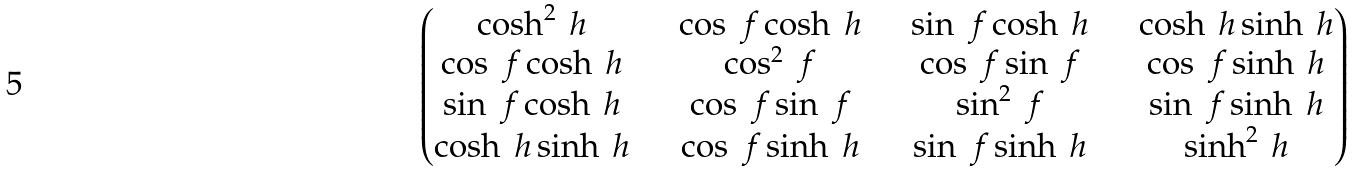Convert formula to latex. <formula><loc_0><loc_0><loc_500><loc_500>\begin{pmatrix} \cosh ^ { 2 } \ h & \quad \cos \ f \cosh \ h & \quad \sin \ f \cosh \ h & \quad \cosh \ h \sinh \ h \\ \cos \ f \cosh \ h & \quad \cos ^ { 2 } \ f & \quad \cos \ f \sin \ f & \quad \cos \ f \sinh \ h \\ \sin \ f \cosh \ h & \quad \cos \ f \sin \ f & \quad \sin ^ { 2 } \ f & \quad \sin \ f \sinh \ h \\ \cosh \ h \sinh \ h & \quad \cos \ f \sinh \ h & \quad \sin \ f \sinh \ h & \quad \sinh ^ { 2 } \ h \end{pmatrix}</formula> 